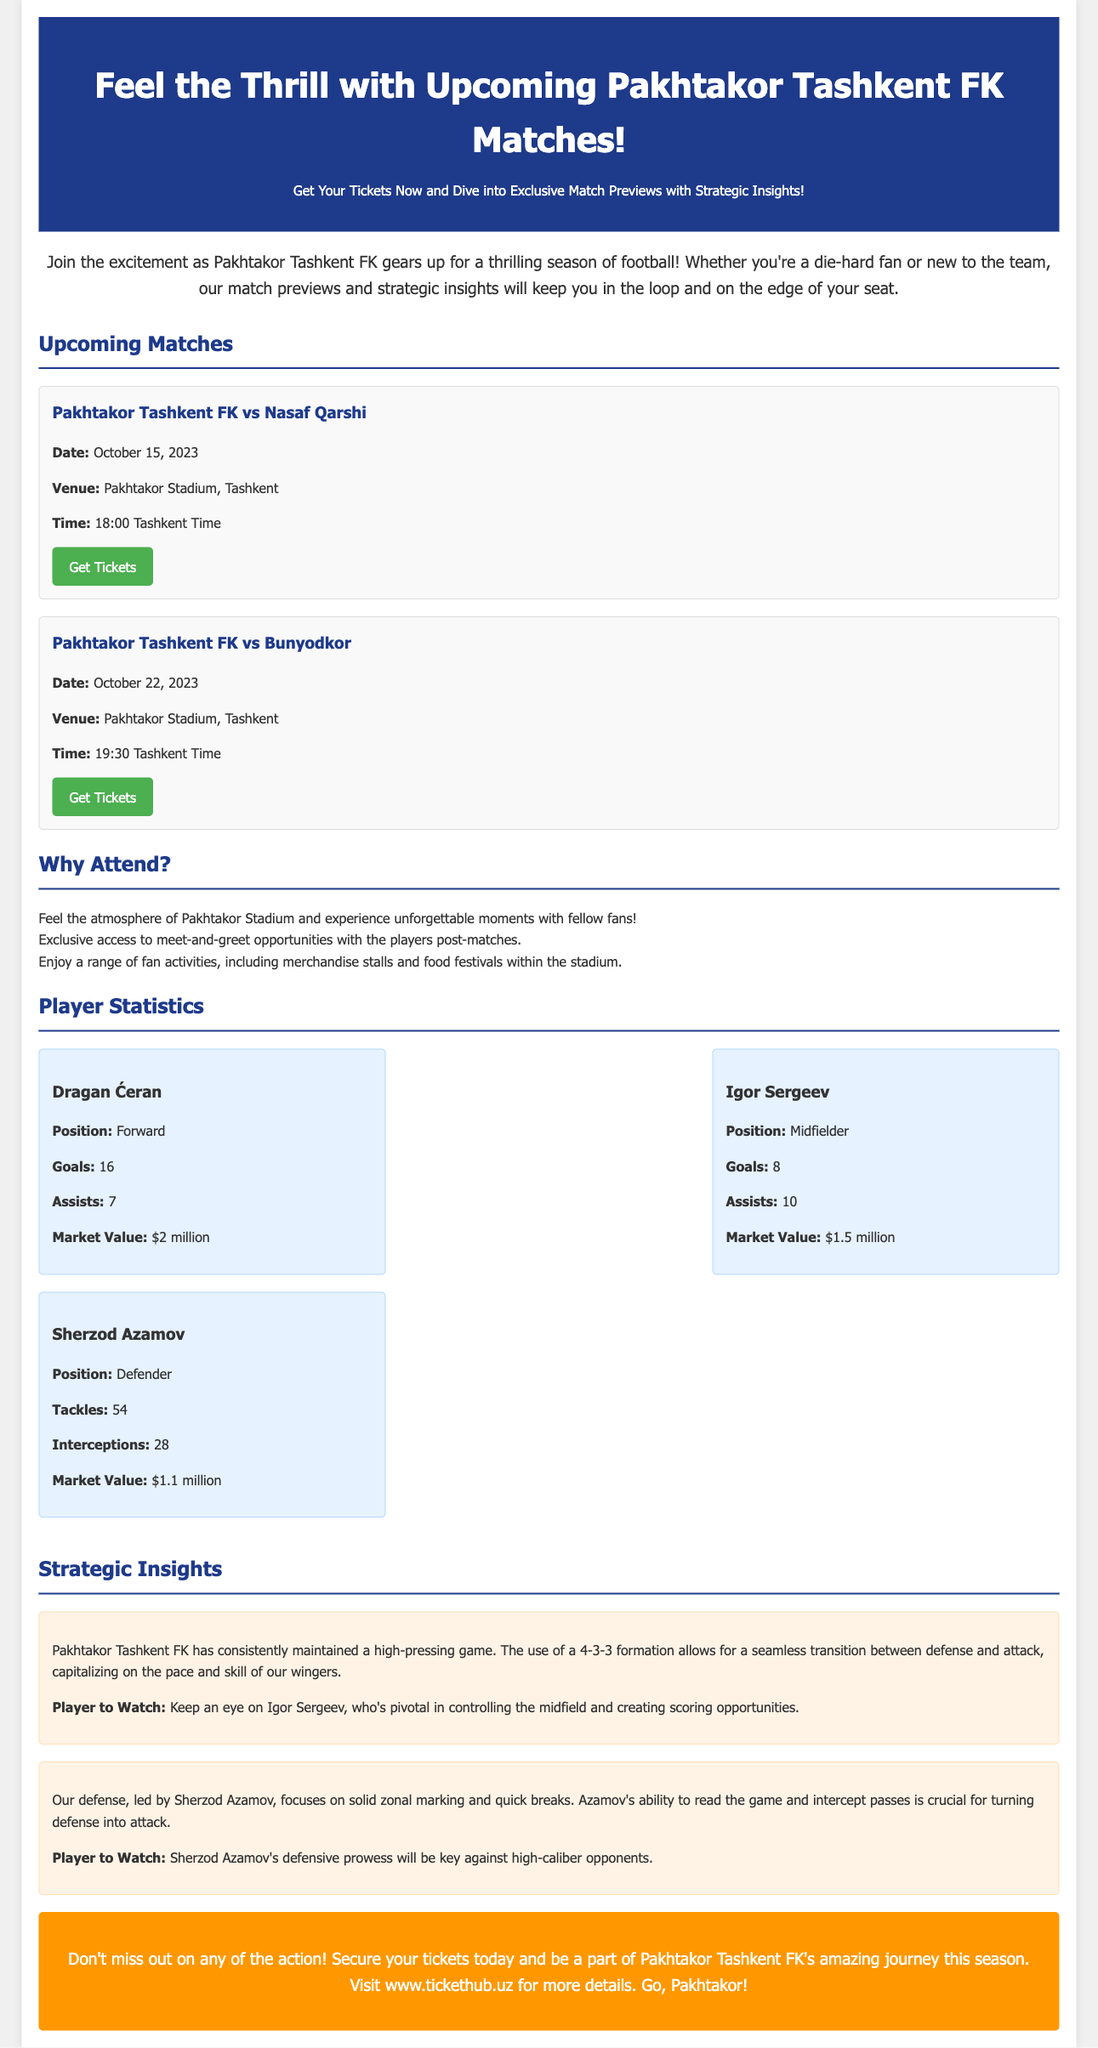What is the date of the match against Nasaf Qarshi? The date of the match against Nasaf Qarshi is provided in the match details section.
Answer: October 15, 2023 Where will the match against Bunyodkor take place? The venue for the match against Bunyodkor is mentioned alongside the match details.
Answer: Pakhtakor Stadium, Tashkent Who is the player with the highest goals this season? The player with the highest goals is indicated in the player statistics section, where each player's goals are listed.
Answer: Dragan Ćeran What is Igor Sergeev's position? Igor Sergeev's position is explicitly stated in the player statistics for each player.
Answer: Midfielder What formation does Pakhtakor Tashkent FK use? The formation utilized by Pakhtakor Tashkent FK is described in the strategic insights section.
Answer: 4-3-3 What time is the match against Nasaf Qarshi? The time for the match is detailed in the match information provided for each game.
Answer: 18:00 Tashkent Time What type of fans activities are mentioned? The document describes various activities available during the matches in the "Why Attend?" section.
Answer: Merchandise stalls and food festivals Who should fans keep an eye on as the player to watch? The players highlighted as critical in the strategic insights section are named as "Player to Watch."
Answer: Igor Sergeev and Sherzod Azamov 